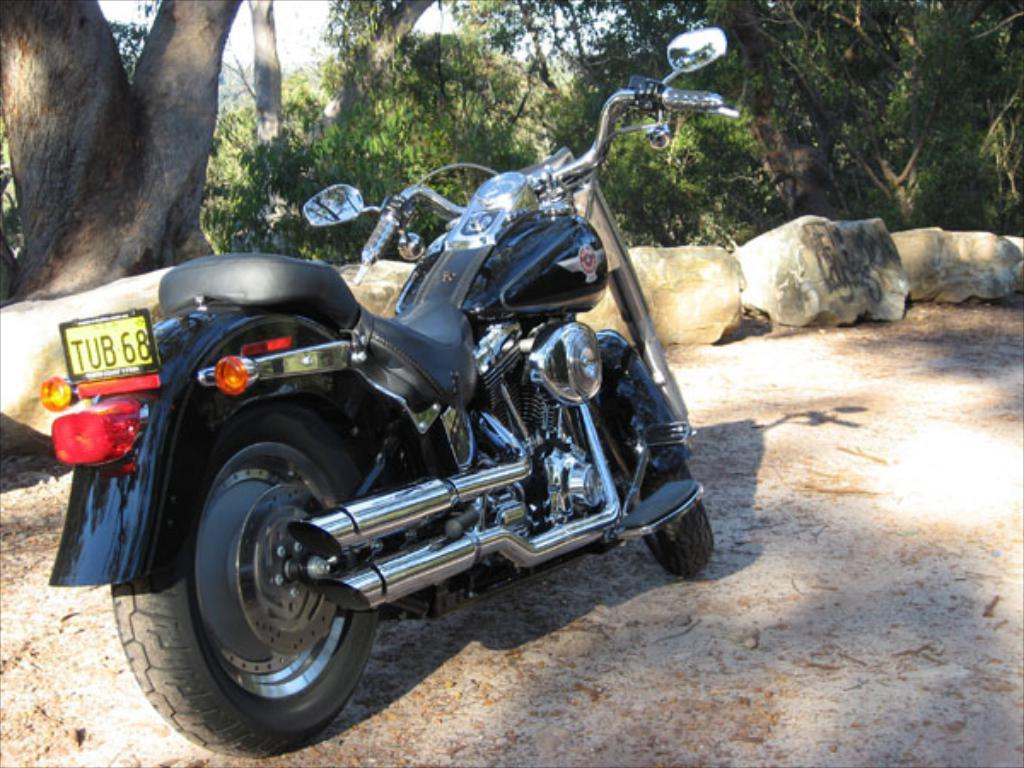What type of vehicle is in the image? There is a black bike in the image. What can be seen at the bottom of the image? The ground is visible at the bottom of the image. What is present in the background of the image? There are rocks and trees in the background of the image. What is visible at the top of the image? The sky is visible at the top of the image. What is the rate at which the bike's leg is pedaling in the image? There is no indication of the bike's leg pedaling in the image, as bikes do not have legs. 